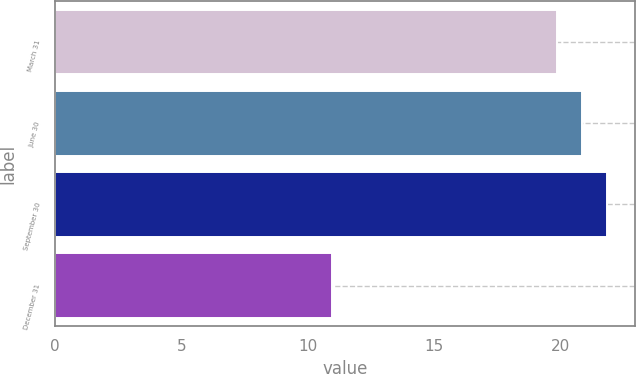Convert chart to OTSL. <chart><loc_0><loc_0><loc_500><loc_500><bar_chart><fcel>March 31<fcel>June 30<fcel>September 30<fcel>December 31<nl><fcel>19.84<fcel>20.84<fcel>21.84<fcel>10.95<nl></chart> 